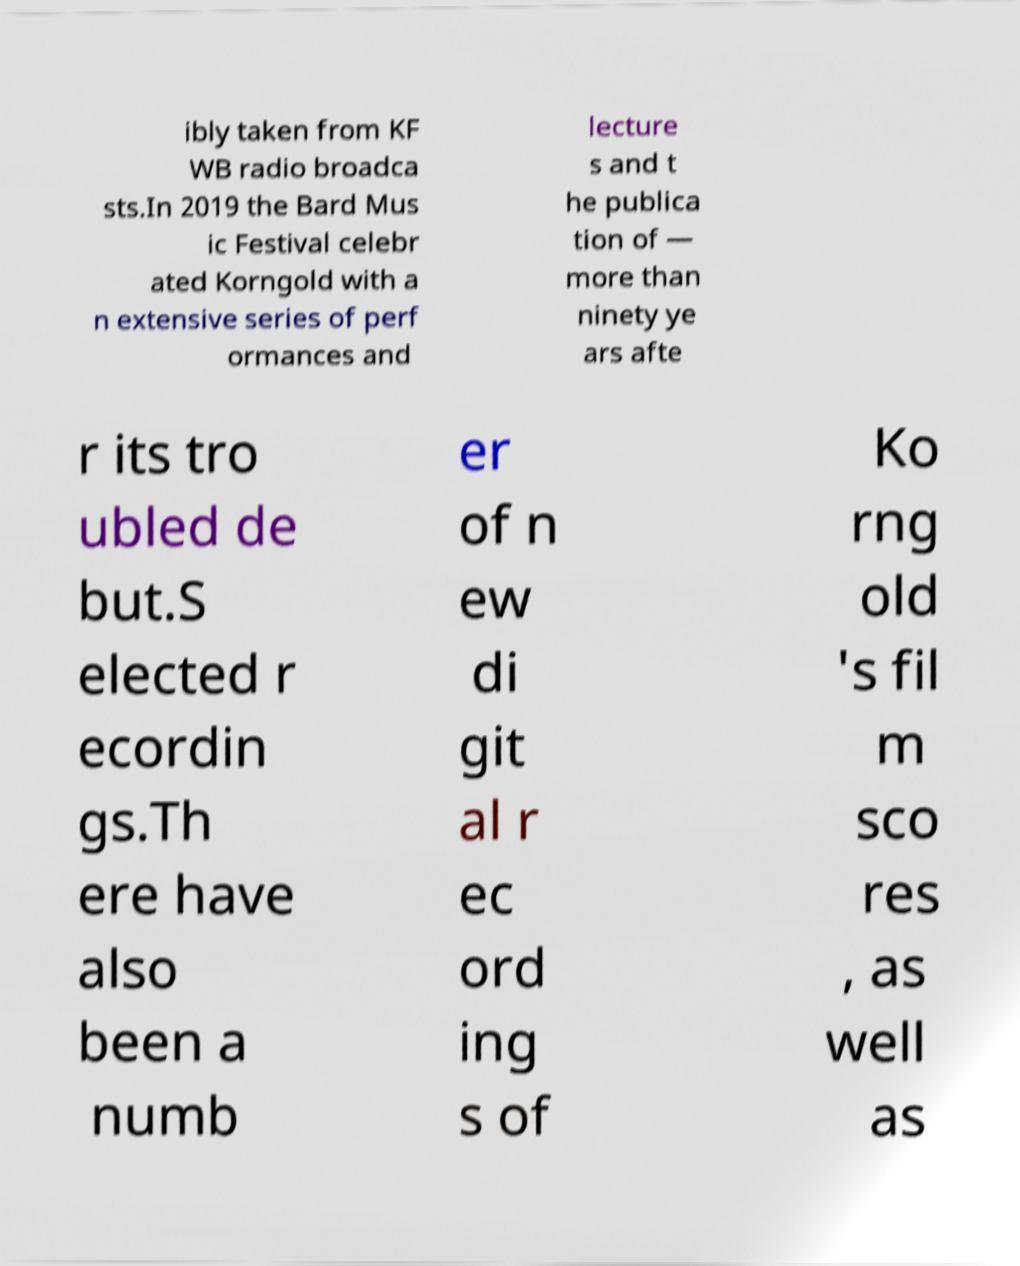Can you read and provide the text displayed in the image?This photo seems to have some interesting text. Can you extract and type it out for me? ibly taken from KF WB radio broadca sts.In 2019 the Bard Mus ic Festival celebr ated Korngold with a n extensive series of perf ormances and lecture s and t he publica tion of — more than ninety ye ars afte r its tro ubled de but.S elected r ecordin gs.Th ere have also been a numb er of n ew di git al r ec ord ing s of Ko rng old 's fil m sco res , as well as 